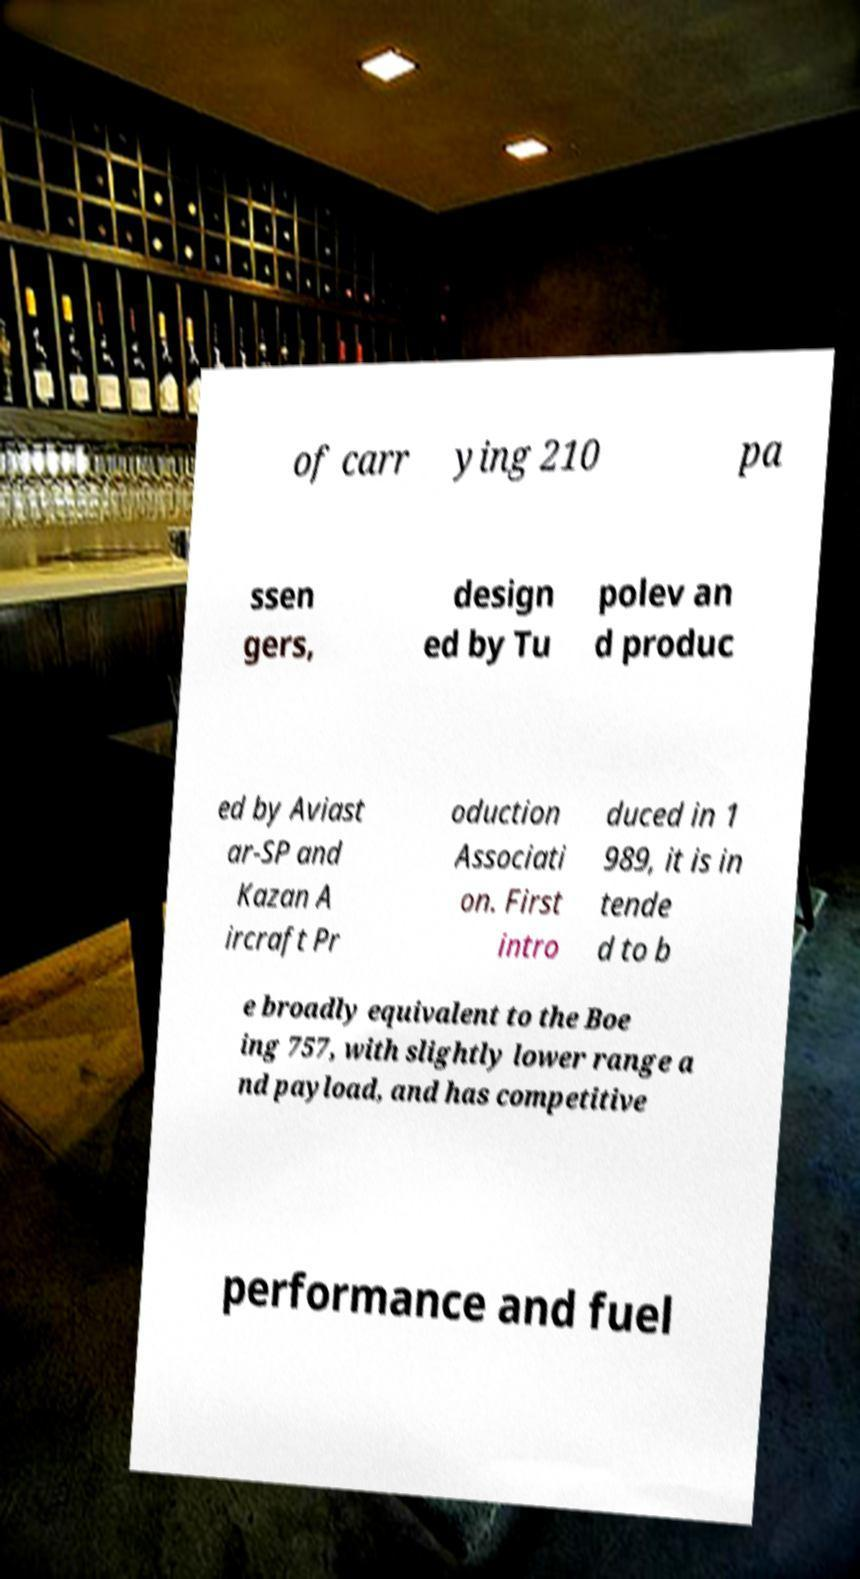There's text embedded in this image that I need extracted. Can you transcribe it verbatim? of carr ying 210 pa ssen gers, design ed by Tu polev an d produc ed by Aviast ar-SP and Kazan A ircraft Pr oduction Associati on. First intro duced in 1 989, it is in tende d to b e broadly equivalent to the Boe ing 757, with slightly lower range a nd payload, and has competitive performance and fuel 